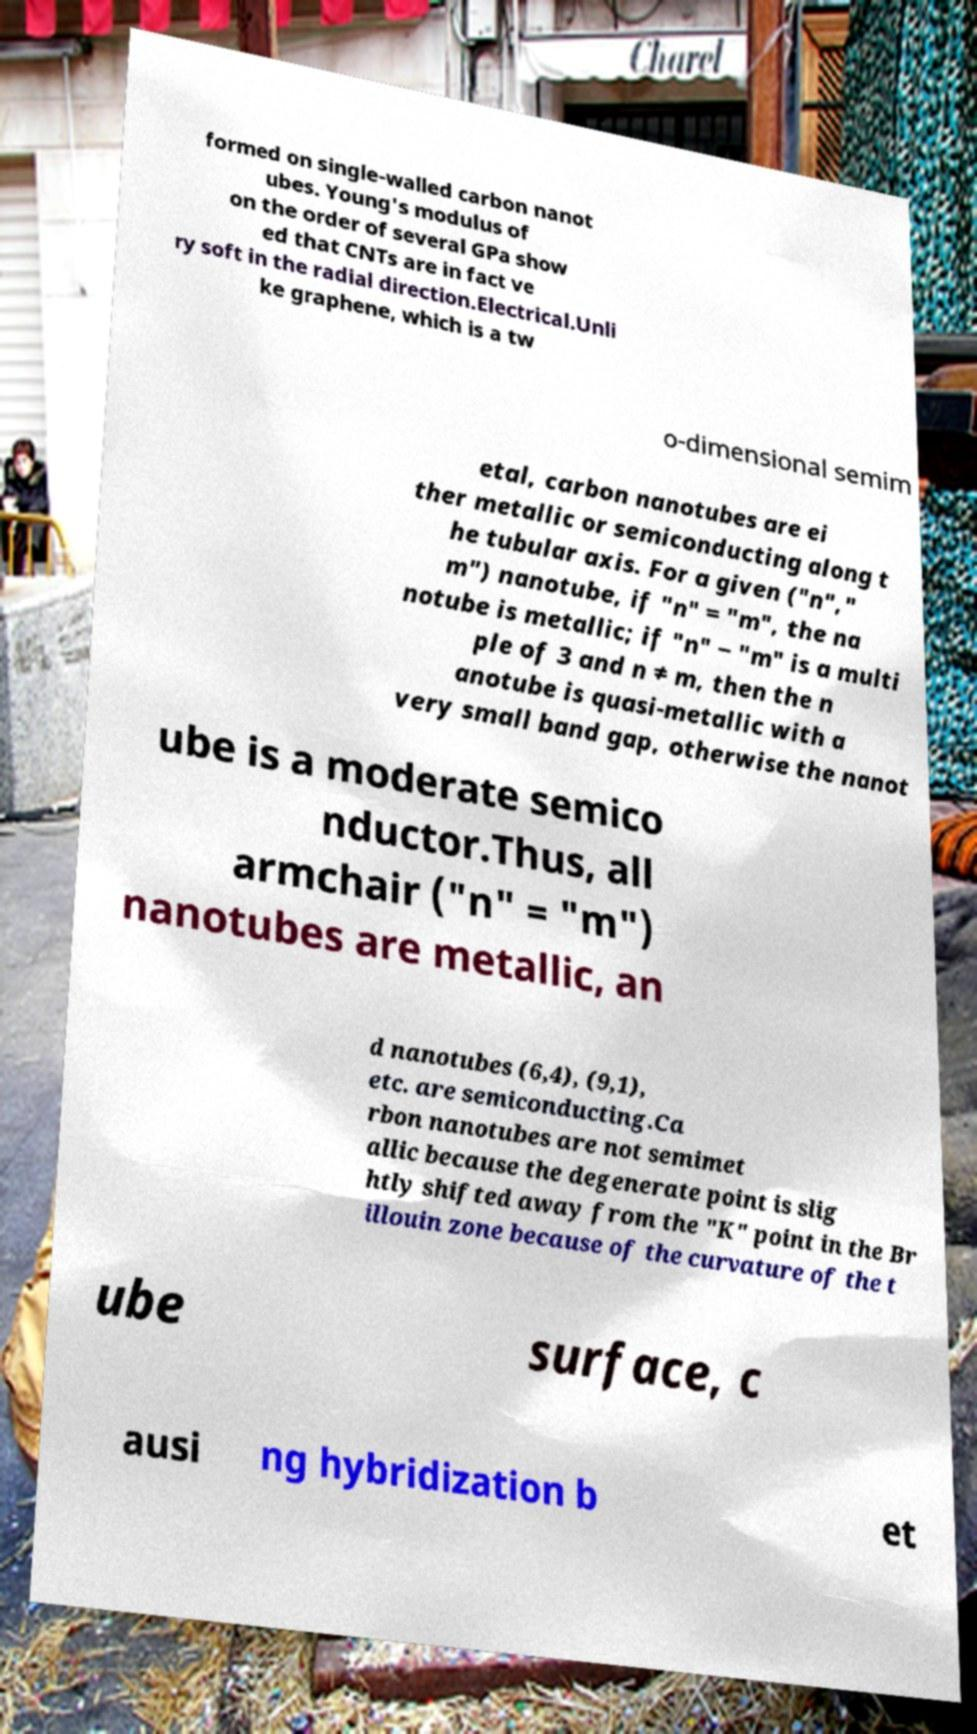Could you assist in decoding the text presented in this image and type it out clearly? formed on single-walled carbon nanot ubes. Young's modulus of on the order of several GPa show ed that CNTs are in fact ve ry soft in the radial direction.Electrical.Unli ke graphene, which is a tw o-dimensional semim etal, carbon nanotubes are ei ther metallic or semiconducting along t he tubular axis. For a given ("n"," m") nanotube, if "n" = "m", the na notube is metallic; if "n" − "m" is a multi ple of 3 and n ≠ m, then the n anotube is quasi-metallic with a very small band gap, otherwise the nanot ube is a moderate semico nductor.Thus, all armchair ("n" = "m") nanotubes are metallic, an d nanotubes (6,4), (9,1), etc. are semiconducting.Ca rbon nanotubes are not semimet allic because the degenerate point is slig htly shifted away from the "K" point in the Br illouin zone because of the curvature of the t ube surface, c ausi ng hybridization b et 